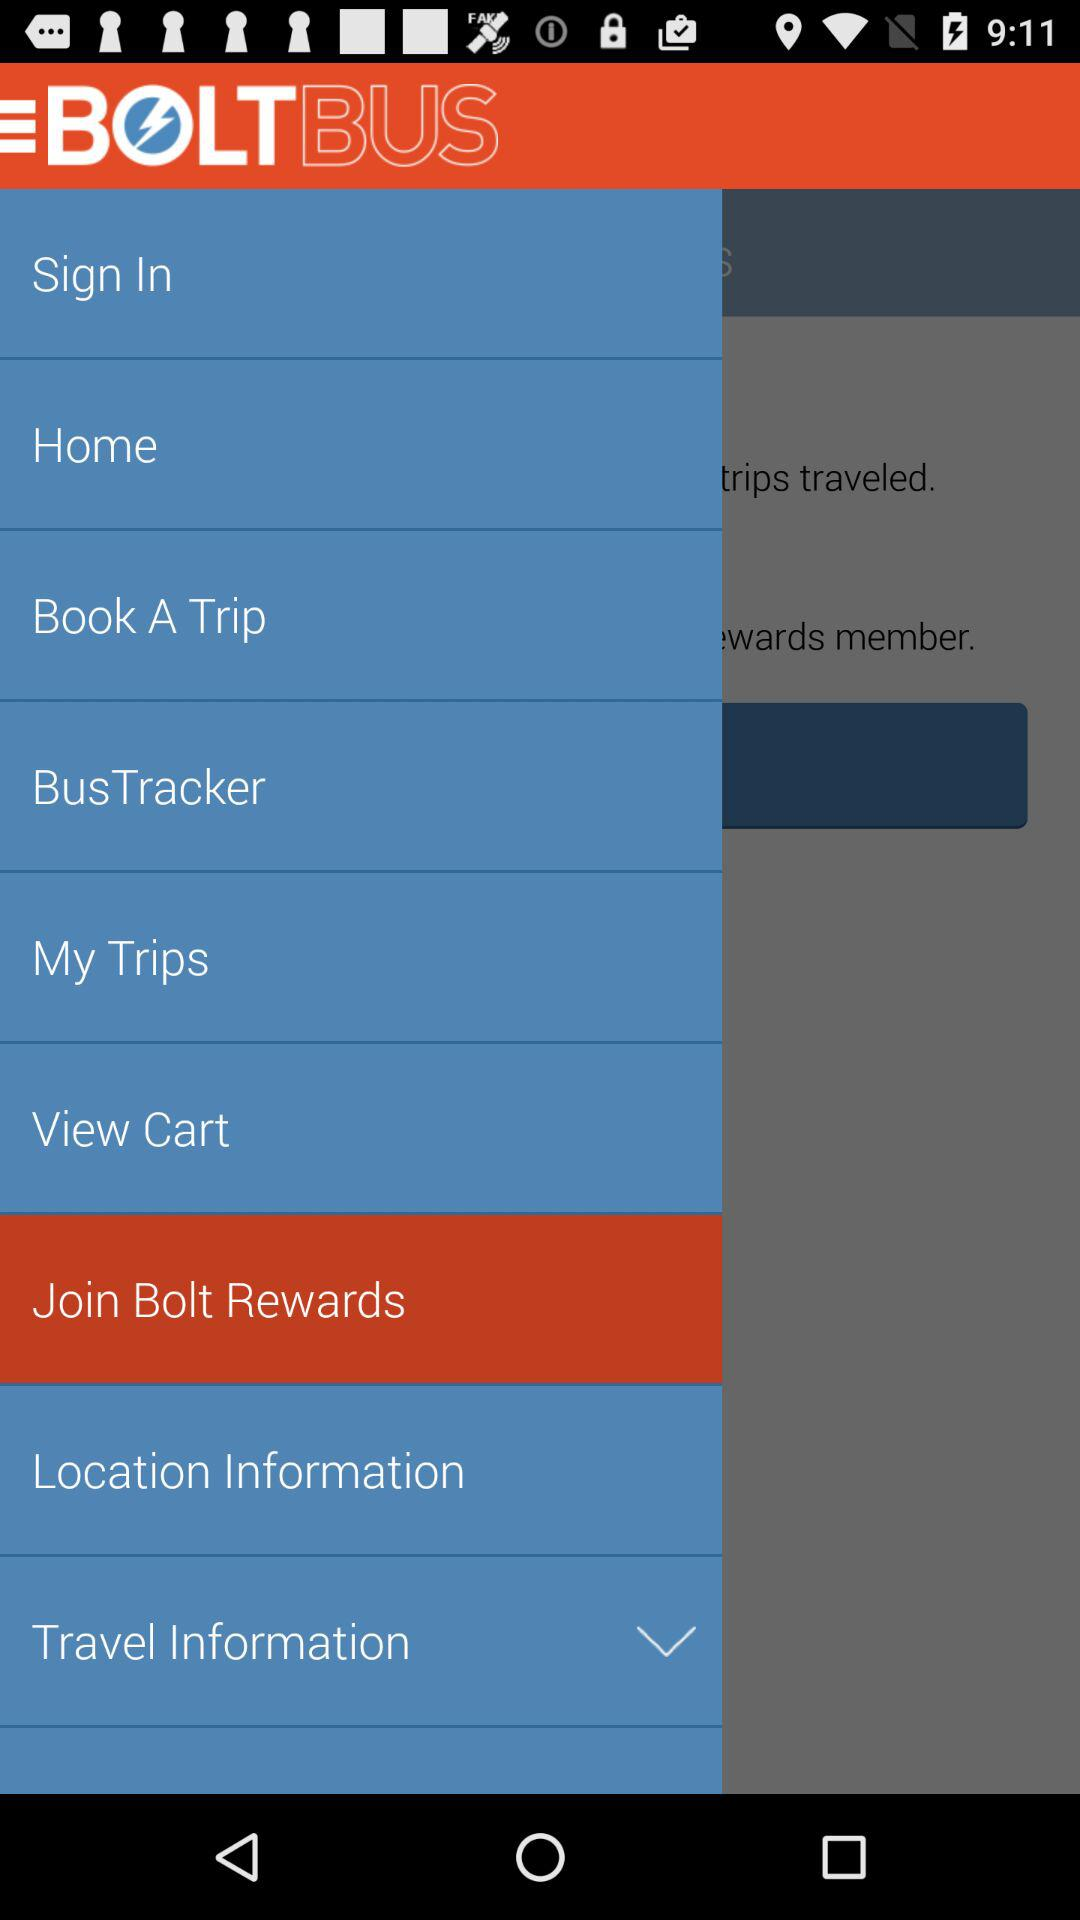What is the application name? The application name is "BOLTBUS". 